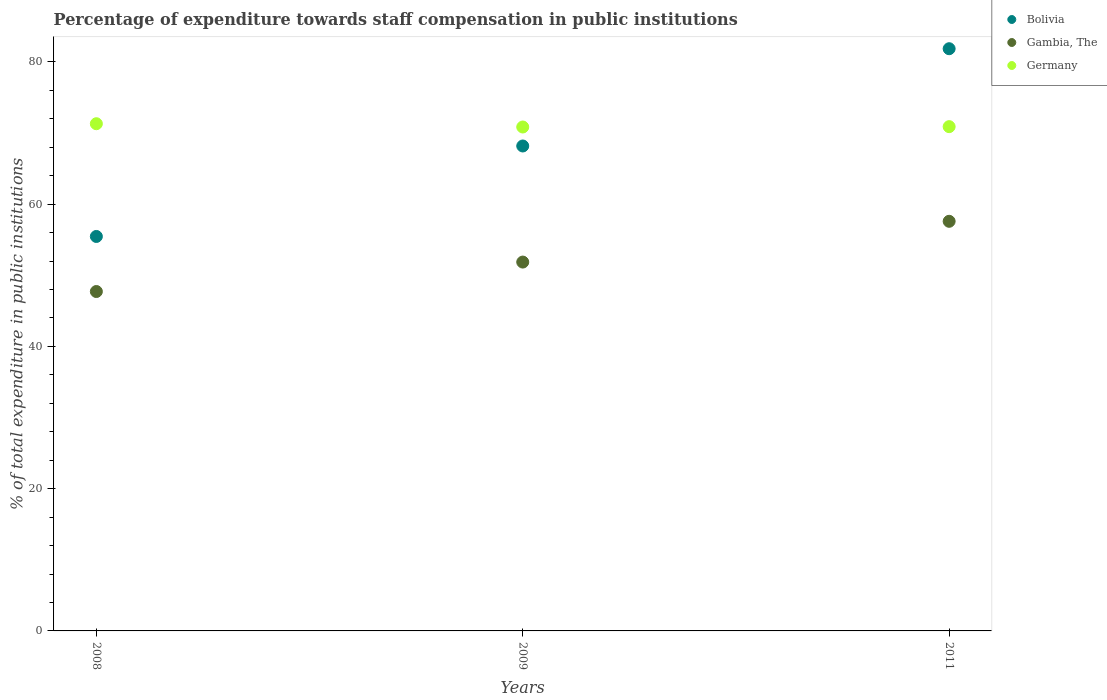How many different coloured dotlines are there?
Ensure brevity in your answer.  3. What is the percentage of expenditure towards staff compensation in Germany in 2011?
Give a very brief answer. 70.89. Across all years, what is the maximum percentage of expenditure towards staff compensation in Gambia, The?
Keep it short and to the point. 57.58. Across all years, what is the minimum percentage of expenditure towards staff compensation in Bolivia?
Your answer should be very brief. 55.46. In which year was the percentage of expenditure towards staff compensation in Germany minimum?
Give a very brief answer. 2009. What is the total percentage of expenditure towards staff compensation in Bolivia in the graph?
Provide a short and direct response. 205.48. What is the difference between the percentage of expenditure towards staff compensation in Bolivia in 2008 and that in 2011?
Ensure brevity in your answer.  -26.39. What is the difference between the percentage of expenditure towards staff compensation in Bolivia in 2011 and the percentage of expenditure towards staff compensation in Germany in 2009?
Keep it short and to the point. 11.01. What is the average percentage of expenditure towards staff compensation in Gambia, The per year?
Your answer should be compact. 52.38. In the year 2011, what is the difference between the percentage of expenditure towards staff compensation in Gambia, The and percentage of expenditure towards staff compensation in Germany?
Provide a short and direct response. -13.31. What is the ratio of the percentage of expenditure towards staff compensation in Germany in 2008 to that in 2009?
Your answer should be very brief. 1.01. Is the percentage of expenditure towards staff compensation in Bolivia in 2009 less than that in 2011?
Provide a succinct answer. Yes. Is the difference between the percentage of expenditure towards staff compensation in Gambia, The in 2008 and 2009 greater than the difference between the percentage of expenditure towards staff compensation in Germany in 2008 and 2009?
Provide a succinct answer. No. What is the difference between the highest and the second highest percentage of expenditure towards staff compensation in Germany?
Your response must be concise. 0.41. What is the difference between the highest and the lowest percentage of expenditure towards staff compensation in Bolivia?
Your answer should be compact. 26.39. Does the percentage of expenditure towards staff compensation in Germany monotonically increase over the years?
Offer a very short reply. No. Is the percentage of expenditure towards staff compensation in Bolivia strictly greater than the percentage of expenditure towards staff compensation in Germany over the years?
Offer a terse response. No. Is the percentage of expenditure towards staff compensation in Bolivia strictly less than the percentage of expenditure towards staff compensation in Gambia, The over the years?
Ensure brevity in your answer.  No. How many dotlines are there?
Give a very brief answer. 3. How many years are there in the graph?
Keep it short and to the point. 3. Are the values on the major ticks of Y-axis written in scientific E-notation?
Keep it short and to the point. No. Does the graph contain any zero values?
Provide a succinct answer. No. Where does the legend appear in the graph?
Provide a short and direct response. Top right. How many legend labels are there?
Your answer should be very brief. 3. How are the legend labels stacked?
Your response must be concise. Vertical. What is the title of the graph?
Give a very brief answer. Percentage of expenditure towards staff compensation in public institutions. What is the label or title of the Y-axis?
Offer a terse response. % of total expenditure in public institutions. What is the % of total expenditure in public institutions of Bolivia in 2008?
Ensure brevity in your answer.  55.46. What is the % of total expenditure in public institutions of Gambia, The in 2008?
Your response must be concise. 47.71. What is the % of total expenditure in public institutions of Germany in 2008?
Ensure brevity in your answer.  71.3. What is the % of total expenditure in public institutions of Bolivia in 2009?
Make the answer very short. 68.17. What is the % of total expenditure in public institutions in Gambia, The in 2009?
Your answer should be compact. 51.85. What is the % of total expenditure in public institutions of Germany in 2009?
Your answer should be compact. 70.84. What is the % of total expenditure in public institutions of Bolivia in 2011?
Keep it short and to the point. 81.85. What is the % of total expenditure in public institutions of Gambia, The in 2011?
Offer a very short reply. 57.58. What is the % of total expenditure in public institutions in Germany in 2011?
Your answer should be very brief. 70.89. Across all years, what is the maximum % of total expenditure in public institutions in Bolivia?
Keep it short and to the point. 81.85. Across all years, what is the maximum % of total expenditure in public institutions in Gambia, The?
Offer a terse response. 57.58. Across all years, what is the maximum % of total expenditure in public institutions of Germany?
Offer a terse response. 71.3. Across all years, what is the minimum % of total expenditure in public institutions in Bolivia?
Your answer should be very brief. 55.46. Across all years, what is the minimum % of total expenditure in public institutions of Gambia, The?
Give a very brief answer. 47.71. Across all years, what is the minimum % of total expenditure in public institutions of Germany?
Ensure brevity in your answer.  70.84. What is the total % of total expenditure in public institutions in Bolivia in the graph?
Keep it short and to the point. 205.48. What is the total % of total expenditure in public institutions of Gambia, The in the graph?
Offer a terse response. 157.15. What is the total % of total expenditure in public institutions of Germany in the graph?
Offer a terse response. 213.04. What is the difference between the % of total expenditure in public institutions of Bolivia in 2008 and that in 2009?
Keep it short and to the point. -12.72. What is the difference between the % of total expenditure in public institutions of Gambia, The in 2008 and that in 2009?
Offer a terse response. -4.14. What is the difference between the % of total expenditure in public institutions of Germany in 2008 and that in 2009?
Your answer should be compact. 0.46. What is the difference between the % of total expenditure in public institutions in Bolivia in 2008 and that in 2011?
Provide a short and direct response. -26.39. What is the difference between the % of total expenditure in public institutions in Gambia, The in 2008 and that in 2011?
Your answer should be compact. -9.87. What is the difference between the % of total expenditure in public institutions of Germany in 2008 and that in 2011?
Keep it short and to the point. 0.41. What is the difference between the % of total expenditure in public institutions in Bolivia in 2009 and that in 2011?
Give a very brief answer. -13.67. What is the difference between the % of total expenditure in public institutions in Gambia, The in 2009 and that in 2011?
Offer a terse response. -5.73. What is the difference between the % of total expenditure in public institutions in Germany in 2009 and that in 2011?
Offer a very short reply. -0.05. What is the difference between the % of total expenditure in public institutions of Bolivia in 2008 and the % of total expenditure in public institutions of Gambia, The in 2009?
Offer a very short reply. 3.6. What is the difference between the % of total expenditure in public institutions of Bolivia in 2008 and the % of total expenditure in public institutions of Germany in 2009?
Provide a short and direct response. -15.39. What is the difference between the % of total expenditure in public institutions in Gambia, The in 2008 and the % of total expenditure in public institutions in Germany in 2009?
Keep it short and to the point. -23.13. What is the difference between the % of total expenditure in public institutions in Bolivia in 2008 and the % of total expenditure in public institutions in Gambia, The in 2011?
Your response must be concise. -2.13. What is the difference between the % of total expenditure in public institutions of Bolivia in 2008 and the % of total expenditure in public institutions of Germany in 2011?
Keep it short and to the point. -15.44. What is the difference between the % of total expenditure in public institutions in Gambia, The in 2008 and the % of total expenditure in public institutions in Germany in 2011?
Your answer should be very brief. -23.18. What is the difference between the % of total expenditure in public institutions of Bolivia in 2009 and the % of total expenditure in public institutions of Gambia, The in 2011?
Provide a short and direct response. 10.59. What is the difference between the % of total expenditure in public institutions of Bolivia in 2009 and the % of total expenditure in public institutions of Germany in 2011?
Your answer should be very brief. -2.72. What is the difference between the % of total expenditure in public institutions of Gambia, The in 2009 and the % of total expenditure in public institutions of Germany in 2011?
Provide a short and direct response. -19.04. What is the average % of total expenditure in public institutions in Bolivia per year?
Provide a succinct answer. 68.49. What is the average % of total expenditure in public institutions in Gambia, The per year?
Your answer should be very brief. 52.38. What is the average % of total expenditure in public institutions in Germany per year?
Offer a terse response. 71.01. In the year 2008, what is the difference between the % of total expenditure in public institutions of Bolivia and % of total expenditure in public institutions of Gambia, The?
Offer a terse response. 7.74. In the year 2008, what is the difference between the % of total expenditure in public institutions in Bolivia and % of total expenditure in public institutions in Germany?
Offer a very short reply. -15.85. In the year 2008, what is the difference between the % of total expenditure in public institutions of Gambia, The and % of total expenditure in public institutions of Germany?
Ensure brevity in your answer.  -23.59. In the year 2009, what is the difference between the % of total expenditure in public institutions of Bolivia and % of total expenditure in public institutions of Gambia, The?
Give a very brief answer. 16.32. In the year 2009, what is the difference between the % of total expenditure in public institutions of Bolivia and % of total expenditure in public institutions of Germany?
Keep it short and to the point. -2.67. In the year 2009, what is the difference between the % of total expenditure in public institutions of Gambia, The and % of total expenditure in public institutions of Germany?
Offer a very short reply. -18.99. In the year 2011, what is the difference between the % of total expenditure in public institutions in Bolivia and % of total expenditure in public institutions in Gambia, The?
Your answer should be very brief. 24.26. In the year 2011, what is the difference between the % of total expenditure in public institutions in Bolivia and % of total expenditure in public institutions in Germany?
Offer a terse response. 10.96. In the year 2011, what is the difference between the % of total expenditure in public institutions in Gambia, The and % of total expenditure in public institutions in Germany?
Keep it short and to the point. -13.31. What is the ratio of the % of total expenditure in public institutions in Bolivia in 2008 to that in 2009?
Your response must be concise. 0.81. What is the ratio of the % of total expenditure in public institutions of Gambia, The in 2008 to that in 2009?
Offer a terse response. 0.92. What is the ratio of the % of total expenditure in public institutions of Germany in 2008 to that in 2009?
Your answer should be very brief. 1.01. What is the ratio of the % of total expenditure in public institutions of Bolivia in 2008 to that in 2011?
Your answer should be very brief. 0.68. What is the ratio of the % of total expenditure in public institutions in Gambia, The in 2008 to that in 2011?
Provide a short and direct response. 0.83. What is the ratio of the % of total expenditure in public institutions in Bolivia in 2009 to that in 2011?
Your answer should be compact. 0.83. What is the ratio of the % of total expenditure in public institutions in Gambia, The in 2009 to that in 2011?
Your answer should be compact. 0.9. What is the difference between the highest and the second highest % of total expenditure in public institutions in Bolivia?
Your response must be concise. 13.67. What is the difference between the highest and the second highest % of total expenditure in public institutions in Gambia, The?
Offer a terse response. 5.73. What is the difference between the highest and the second highest % of total expenditure in public institutions in Germany?
Your answer should be compact. 0.41. What is the difference between the highest and the lowest % of total expenditure in public institutions of Bolivia?
Your answer should be compact. 26.39. What is the difference between the highest and the lowest % of total expenditure in public institutions in Gambia, The?
Ensure brevity in your answer.  9.87. What is the difference between the highest and the lowest % of total expenditure in public institutions in Germany?
Your response must be concise. 0.46. 